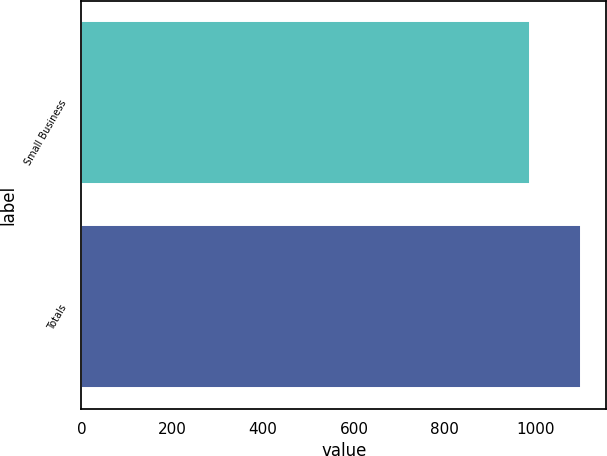<chart> <loc_0><loc_0><loc_500><loc_500><bar_chart><fcel>Small Business<fcel>Totals<nl><fcel>988<fcel>1100<nl></chart> 